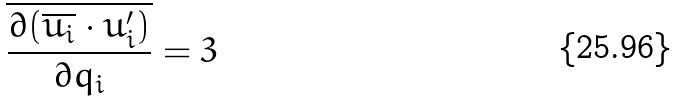Convert formula to latex. <formula><loc_0><loc_0><loc_500><loc_500>\overline { \frac { \partial ( \overline { u _ { i } } \cdot u _ { i } ^ { \prime } ) } { \partial q _ { i } } } = 3</formula> 